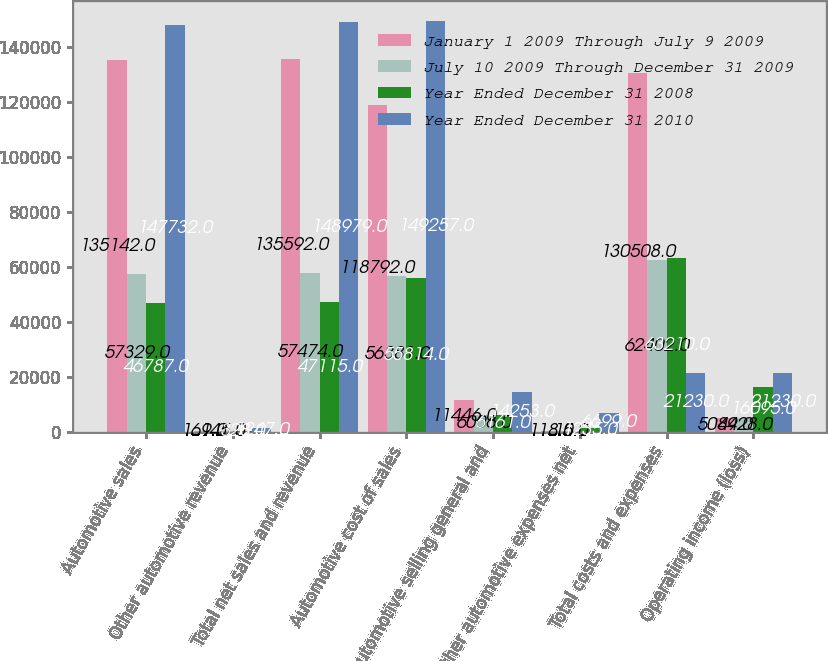Convert chart. <chart><loc_0><loc_0><loc_500><loc_500><stacked_bar_chart><ecel><fcel>Automotive sales<fcel>Other automotive revenue<fcel>Total net sales and revenue<fcel>Automotive cost of sales<fcel>Automotive selling general and<fcel>Other automotive expenses net<fcel>Total costs and expenses<fcel>Operating income (loss)<nl><fcel>January 1 2009 Through July 9 2009<fcel>135142<fcel>169<fcel>135592<fcel>118792<fcel>11446<fcel>118<fcel>130508<fcel>5084<nl><fcel>July 10 2009 Through December 31 2009<fcel>57329<fcel>145<fcel>57474<fcel>56381<fcel>6006<fcel>15<fcel>62402<fcel>4928<nl><fcel>Year Ended December 31 2008<fcel>46787<fcel>328<fcel>47115<fcel>55814<fcel>6161<fcel>1235<fcel>63210<fcel>16095<nl><fcel>Year Ended December 31 2010<fcel>147732<fcel>1247<fcel>148979<fcel>149257<fcel>14253<fcel>6699<fcel>21230<fcel>21230<nl></chart> 